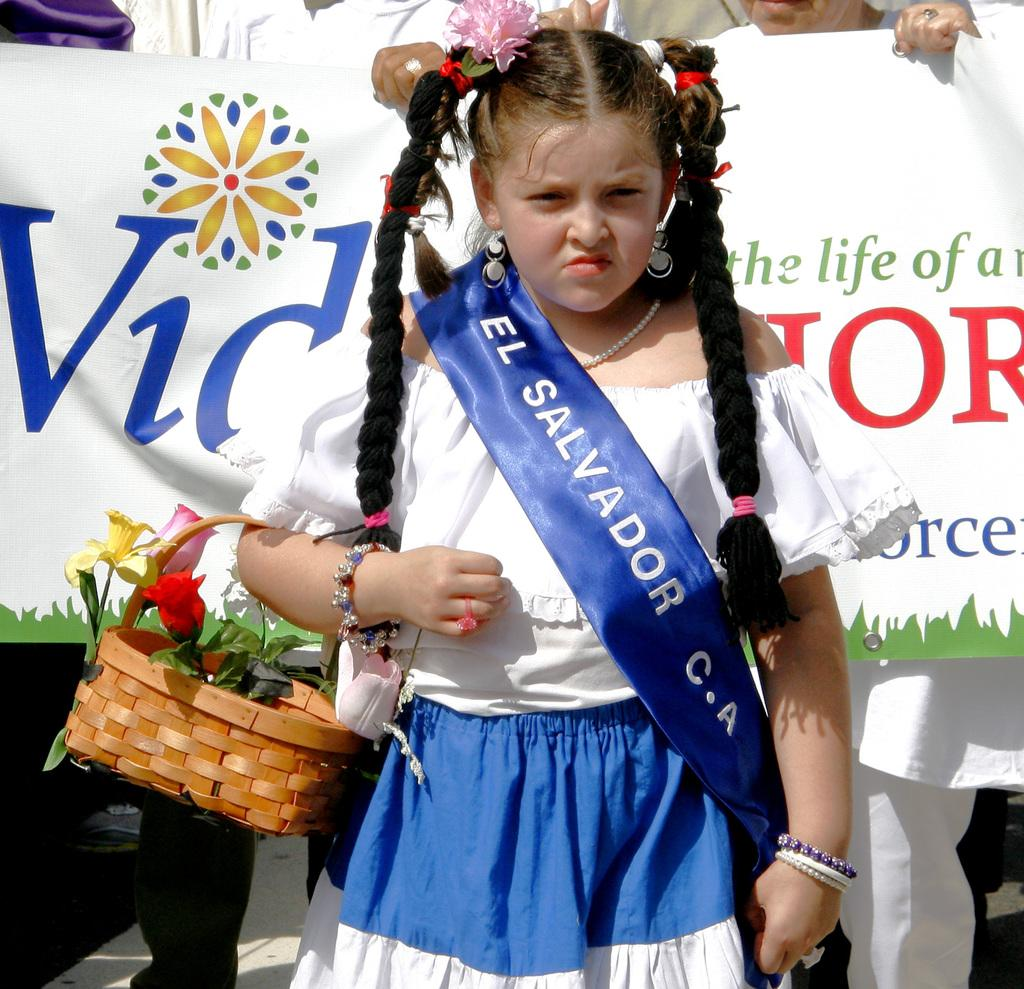Provide a one-sentence caption for the provided image. A young girl wearing a dress and sash representing El Salvador C.A. 